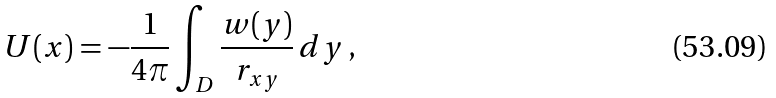Convert formula to latex. <formula><loc_0><loc_0><loc_500><loc_500>U ( x ) = - \frac { 1 } { 4 \pi } \int _ { D } \frac { w ( y ) } { r _ { x y } } \, d y \, { , }</formula> 